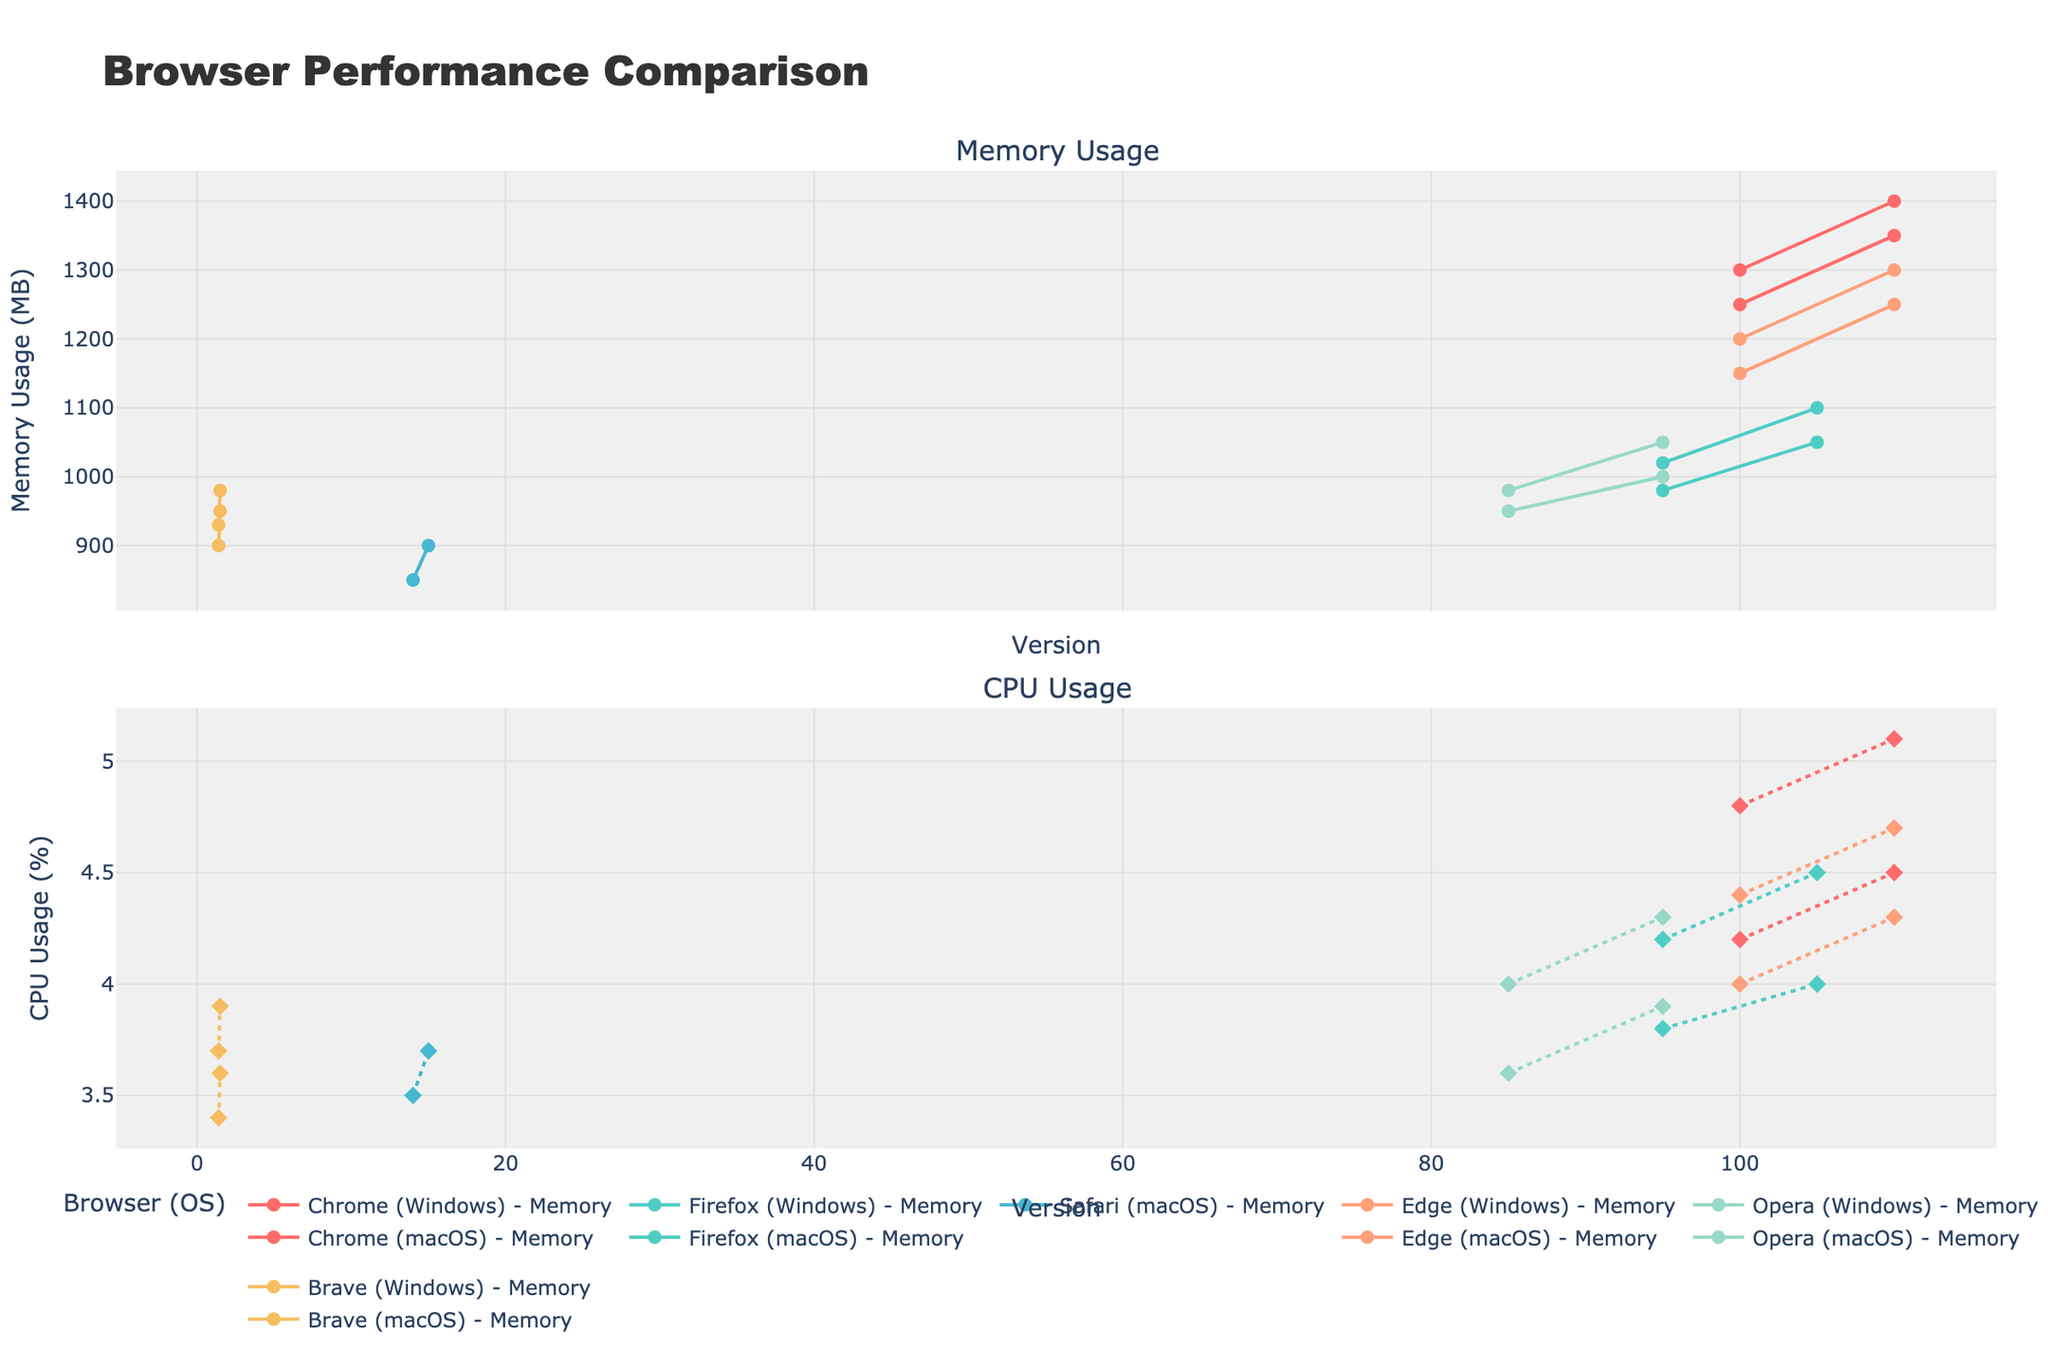Which browser shows the highest memory usage across all versions and operating systems? By looking at the "Memory Usage" subplot, we identify the line with the highest peak among all browsers. The browser with the highest peak in memory usage is Chrome on macOS, at around 1400 MB.
Answer: Chrome Which browser on macOS shows a consistent increase in CPU usage across its versions? By examining the "CPU Usage" subplot and focusing on macOS lines, we see that Chrome on macOS consistently increases from 4.8% to 5.1% across its versions.
Answer: Chrome Between Firefox on Windows and Edge on Windows, which browser has the higher CPU usage in their latest version? Check the "CPU Usage" subplot for the latest versions of Firefox (105) and Edge (110) on Windows. The CPU usage for Firefox is 4.0%, while for Edge it is 4.3%.
Answer: Edge What is the average memory usage of Opera on macOS across its versions? The memory usage values for Opera on macOS are 980 MB and 1050 MB. Calculate the average: (980 + 1050) / 2 = 1015 MB.
Answer: 1015 MB Which browser on Windows has the lowest CPU usage in any of its versions? Examine the "CPU Usage" subplot and find the lowest value among Windows lines. Brave on Windows version 1.40 has the lowest at 3.4%.
Answer: Brave What is the difference in memory usage between Safari on macOS version 14 and version 15? Find the memory usage for Safari on macOS version 14 (850 MB) and version 15 (900 MB). The difference is 900 - 850 = 50 MB.
Answer: 50 MB Which browser and version have the highest CPU usage on macOS? Check the "CPU Usage" subplot for macOS lines and find the highest value. Chrome on macOS version 110 has the highest at 5.1%.
Answer: Chrome 110 Which operating system generally shows higher memory usage for Chrome? Compare the memory usage lines for Chrome on Windows and macOS. Higher values are seen for Chrome on macOS.
Answer: macOS 